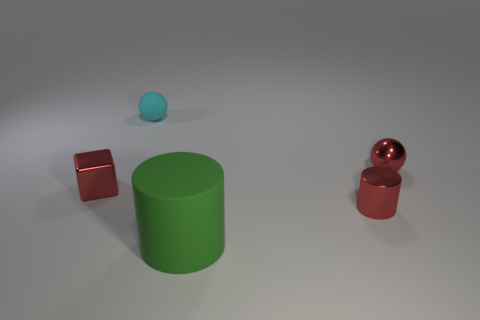Is there any other thing that is the same size as the rubber cylinder?
Offer a terse response. No. The small metallic thing that is both behind the metal cylinder and to the right of the cyan matte thing is what color?
Your answer should be compact. Red. Are there the same number of shiny cylinders that are on the left side of the small metallic cylinder and tiny balls on the left side of the large green cylinder?
Ensure brevity in your answer.  No. There is a cylinder that is made of the same material as the tiny red cube; what is its color?
Keep it short and to the point. Red. There is a metal ball; is its color the same as the shiny object that is in front of the small red block?
Ensure brevity in your answer.  Yes. Is there a cyan thing that is in front of the tiny sphere in front of the small ball that is left of the large green matte cylinder?
Keep it short and to the point. No. The other large thing that is made of the same material as the cyan thing is what shape?
Your answer should be compact. Cylinder. Is there anything else that has the same shape as the small cyan matte object?
Make the answer very short. Yes. What shape is the tiny cyan matte object?
Offer a terse response. Sphere. Does the small red metal object behind the small red shiny cube have the same shape as the cyan matte object?
Keep it short and to the point. Yes. 